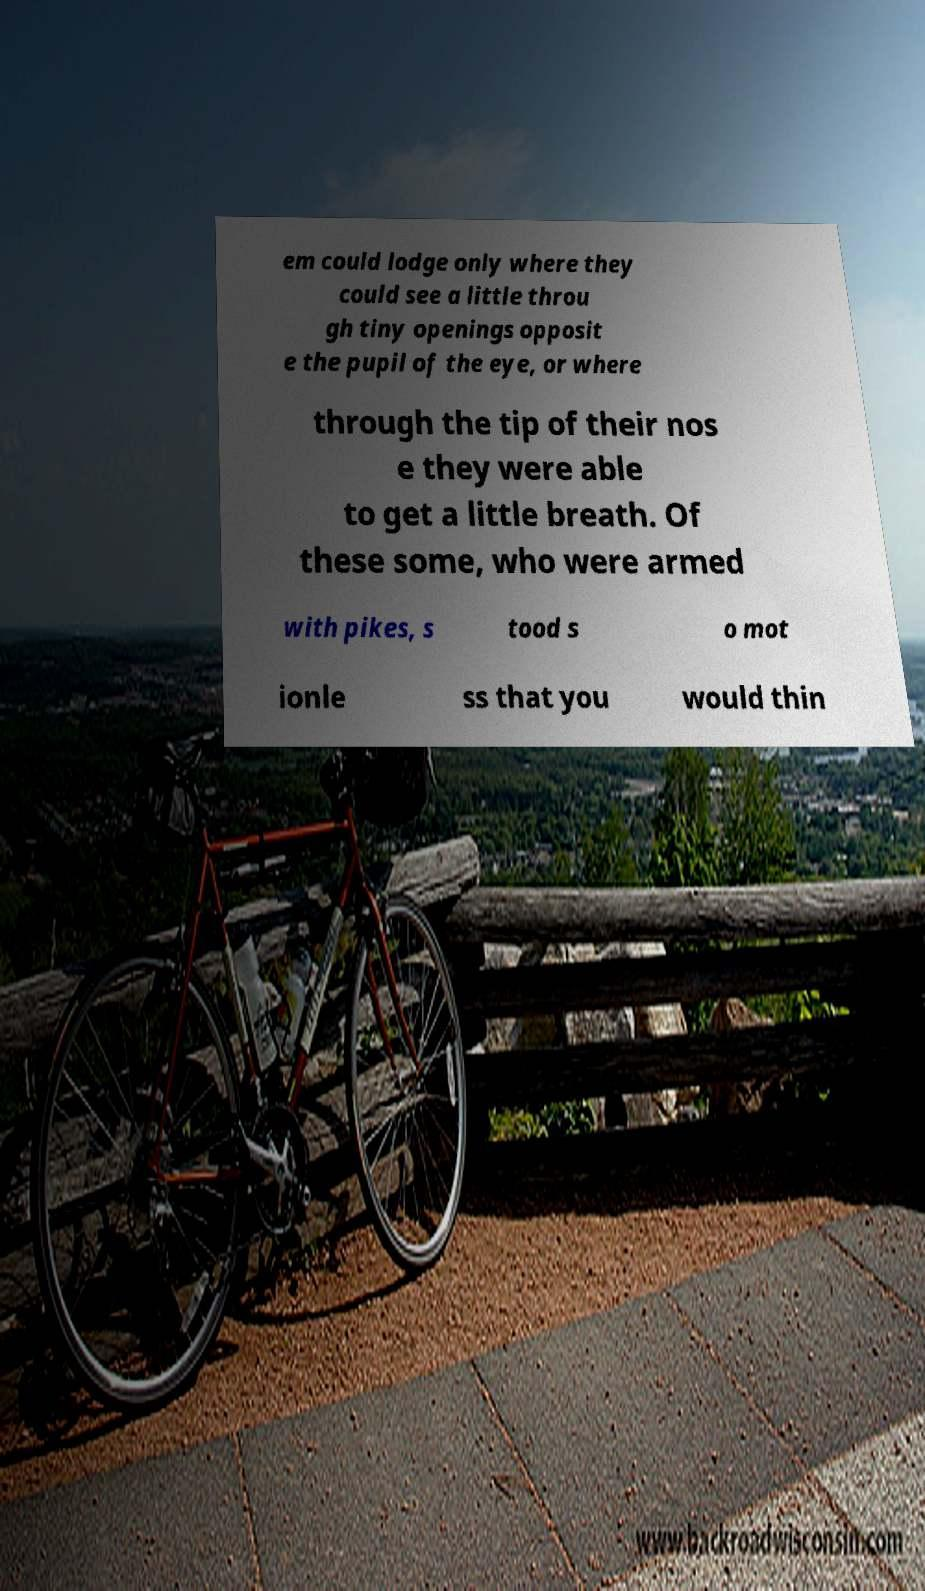I need the written content from this picture converted into text. Can you do that? em could lodge only where they could see a little throu gh tiny openings opposit e the pupil of the eye, or where through the tip of their nos e they were able to get a little breath. Of these some, who were armed with pikes, s tood s o mot ionle ss that you would thin 